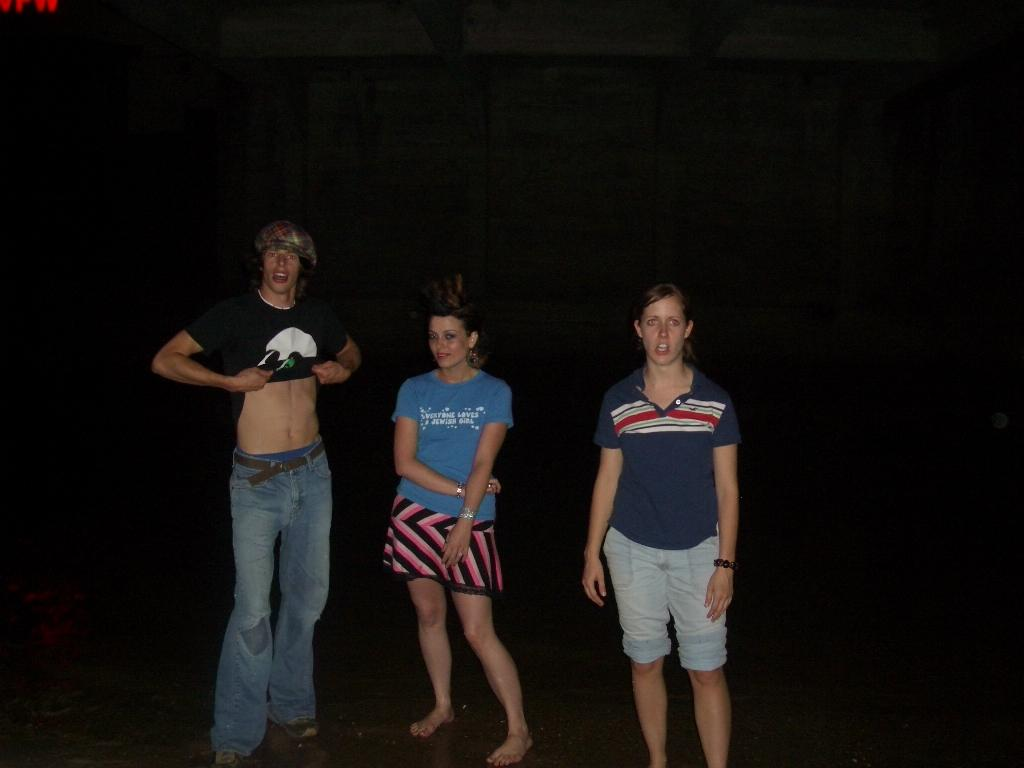<image>
Give a short and clear explanation of the subsequent image. The girl in the middle wears a shirt that says everyone loves a Jewish girl. 